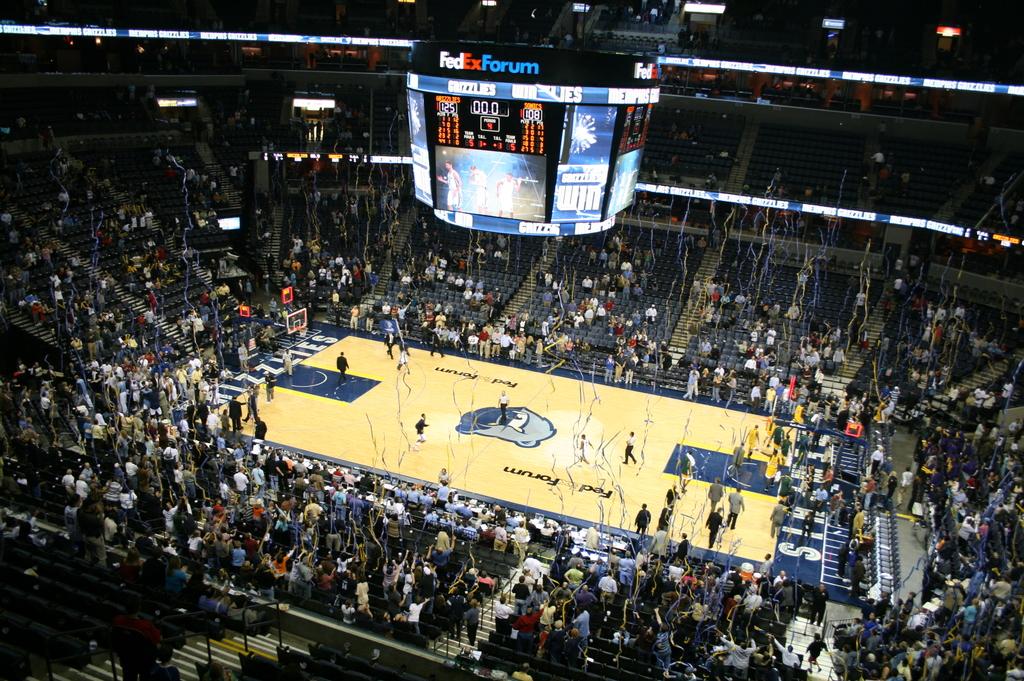What is the name of this stadium?
Your answer should be very brief. Fedex forum. What is the score?
Ensure brevity in your answer.  Unanswerable. 